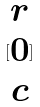<formula> <loc_0><loc_0><loc_500><loc_500>[ \begin{matrix} r \\ 0 \\ c \end{matrix} ]</formula> 